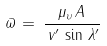Convert formula to latex. <formula><loc_0><loc_0><loc_500><loc_500>\varpi \, = \, \frac { \mu _ { \upsilon } \, A \, } { \, v ^ { \prime } \, \sin \, \lambda ^ { \prime } }</formula> 